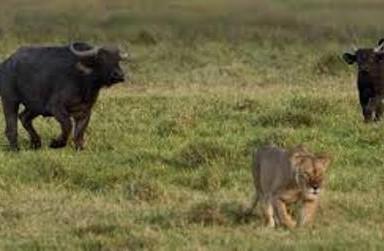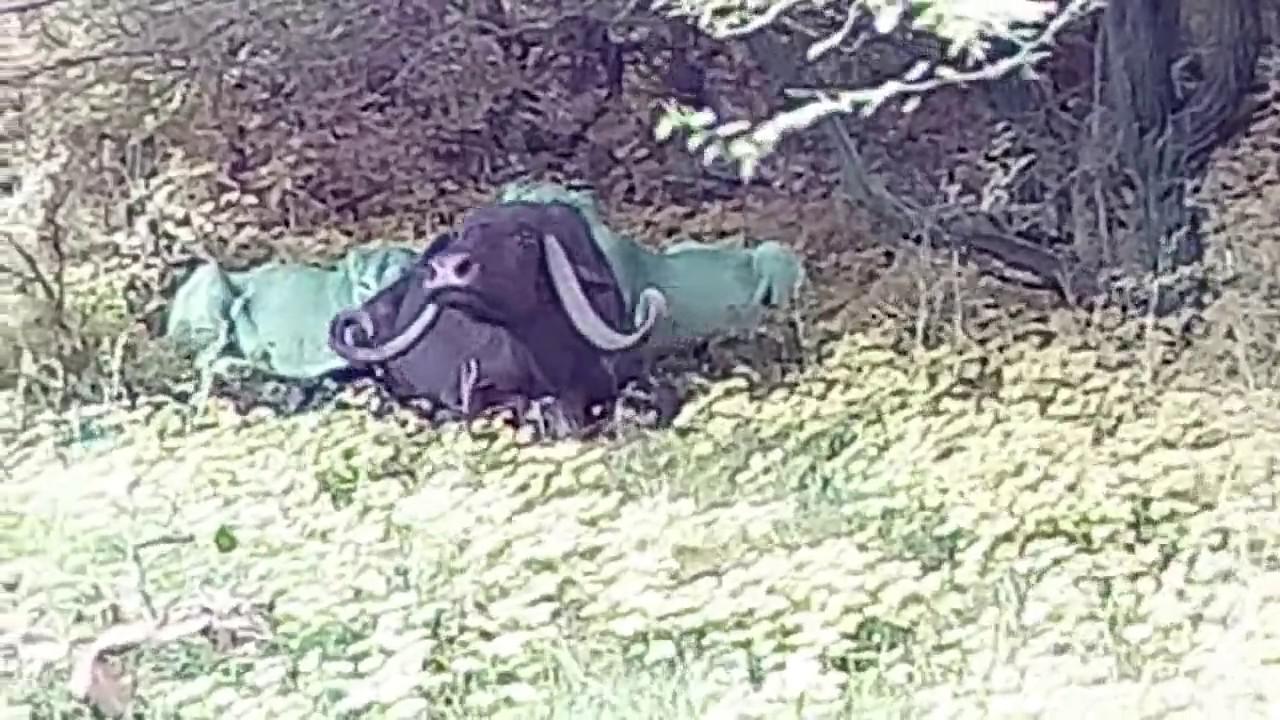The first image is the image on the left, the second image is the image on the right. Evaluate the accuracy of this statement regarding the images: "Two or more humans are visible.". Is it true? Answer yes or no. No. The first image is the image on the left, the second image is the image on the right. Examine the images to the left and right. Is the description "Some animals are laying in mud." accurate? Answer yes or no. No. 